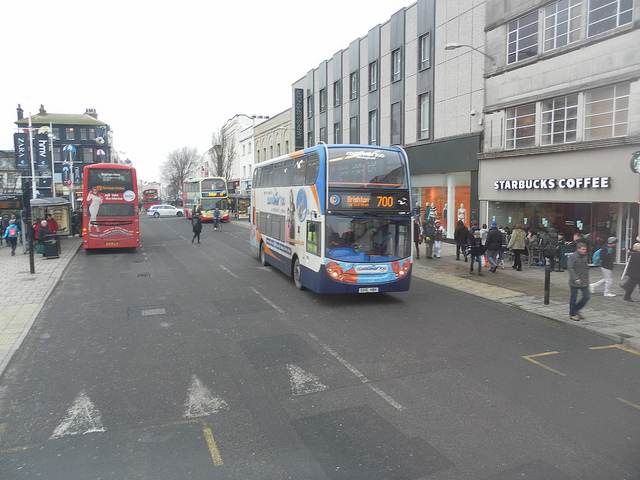Let's create a story about one of the people in this scene. Amidst the bustling city scene, a young woman in a green coat stood in front of Starbucks, clutching her coffee with a look of anticipation. Her name was Clara, and today was a significant day for her. Clara had just secured a big promotion at work, something she had been working tirelessly towards for the past two years. Standing at the bus stop, she took a deep breath, savoring the moment, her mind racing with thoughts of the future. As bus 700 approached, she felt a renewed sense of determination. This city, with its hustle and bustle, was hers to conquer. 